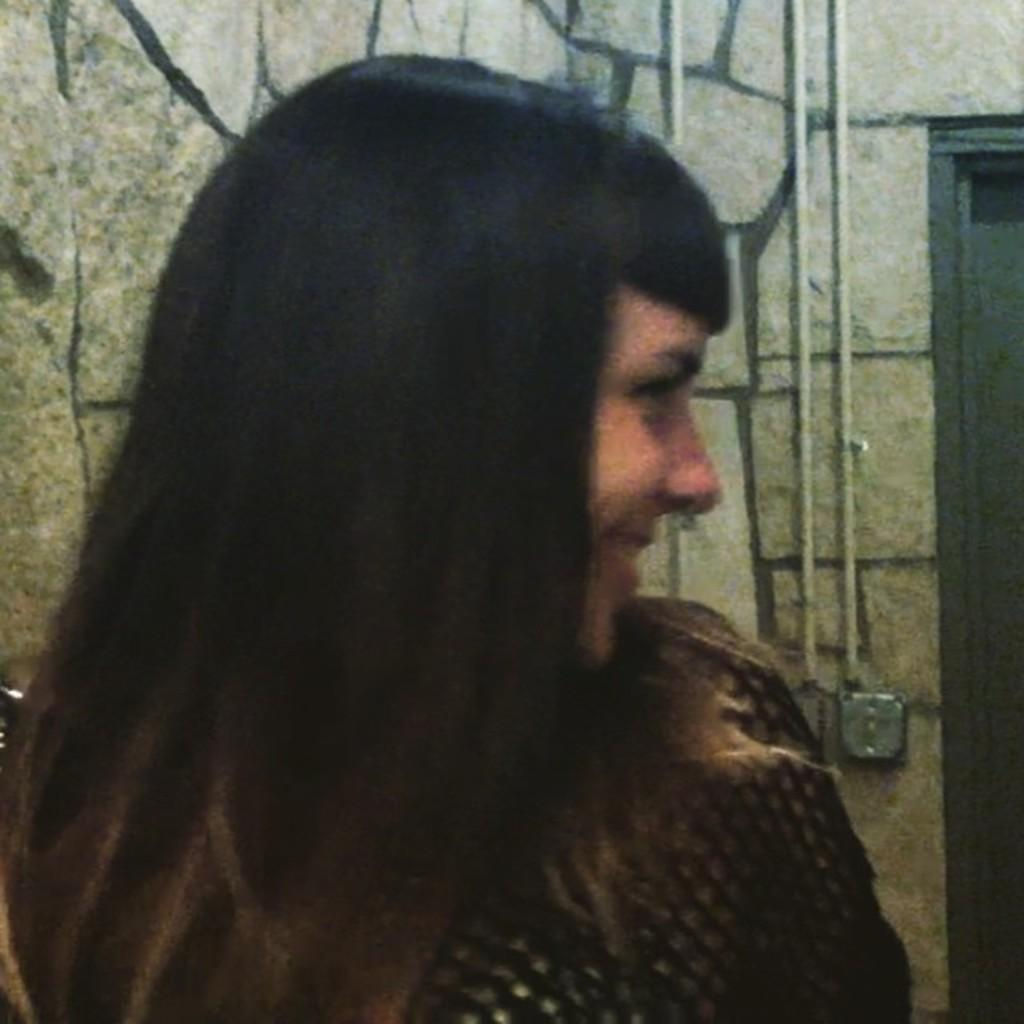Who is present in the image? There is a woman in the image. What is the woman wearing? The woman is wearing a black dress. What can be seen behind the woman? There is a wall in the image. Is there any entrance or exit visible in the image? Yes, there is a door in the image. Can you tell me how many donkeys are standing near the woman in the image? There are no donkeys present in the image; it only features a woman wearing a black dress and a wall with a door. What type of flock can be seen grazing on the bushes in the image? There are no bushes or flocks present in the image. 